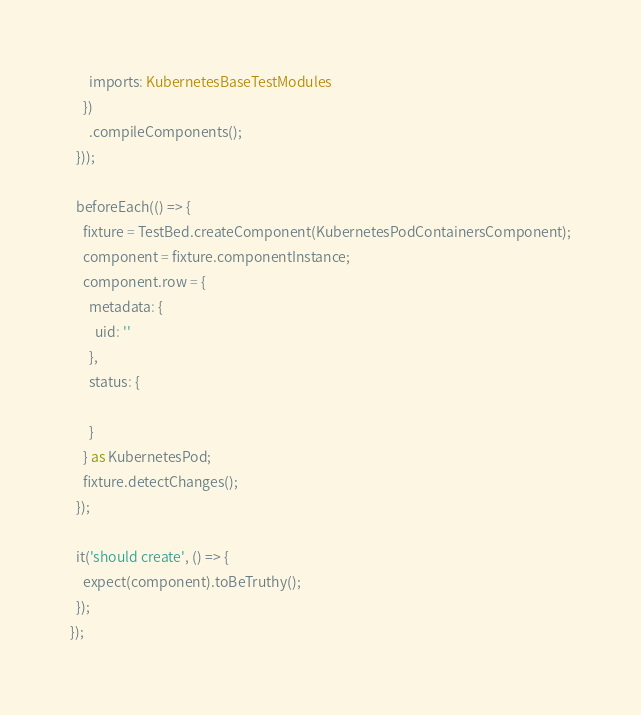Convert code to text. <code><loc_0><loc_0><loc_500><loc_500><_TypeScript_>      imports: KubernetesBaseTestModules
    })
      .compileComponents();
  }));

  beforeEach(() => {
    fixture = TestBed.createComponent(KubernetesPodContainersComponent);
    component = fixture.componentInstance;
    component.row = {
      metadata: {
        uid: ''
      },
      status: {

      }
    } as KubernetesPod;
    fixture.detectChanges();
  });

  it('should create', () => {
    expect(component).toBeTruthy();
  });
});
</code> 